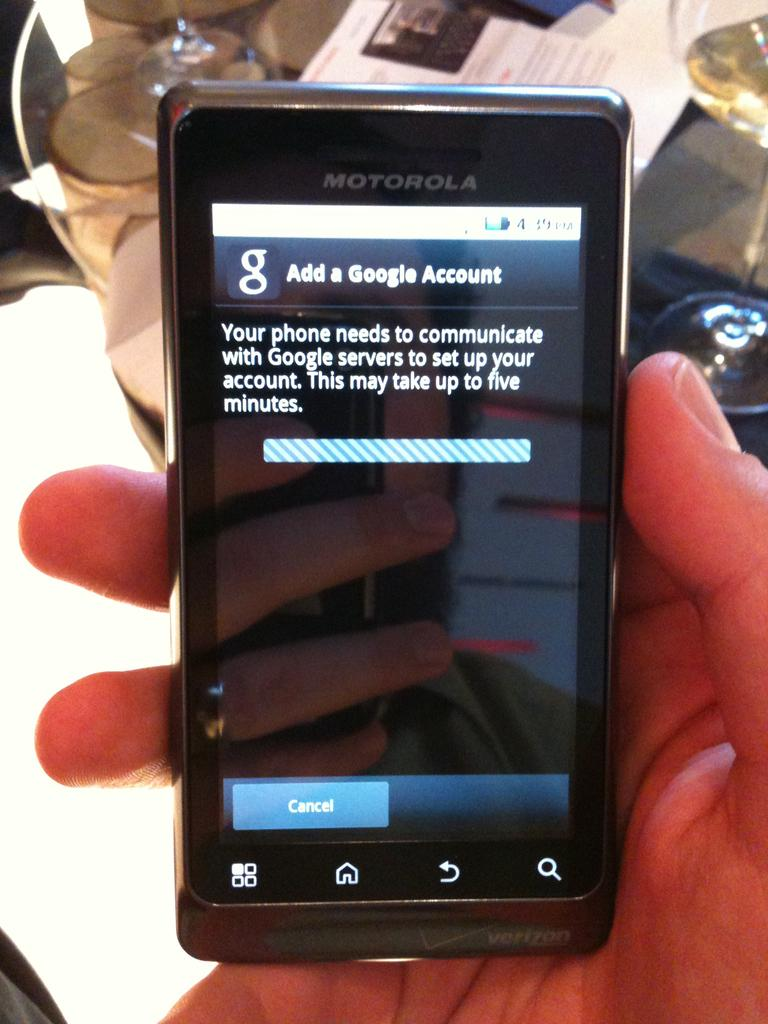<image>
Present a compact description of the photo's key features. a small motorola phone with a page open that says 'add a google account' 